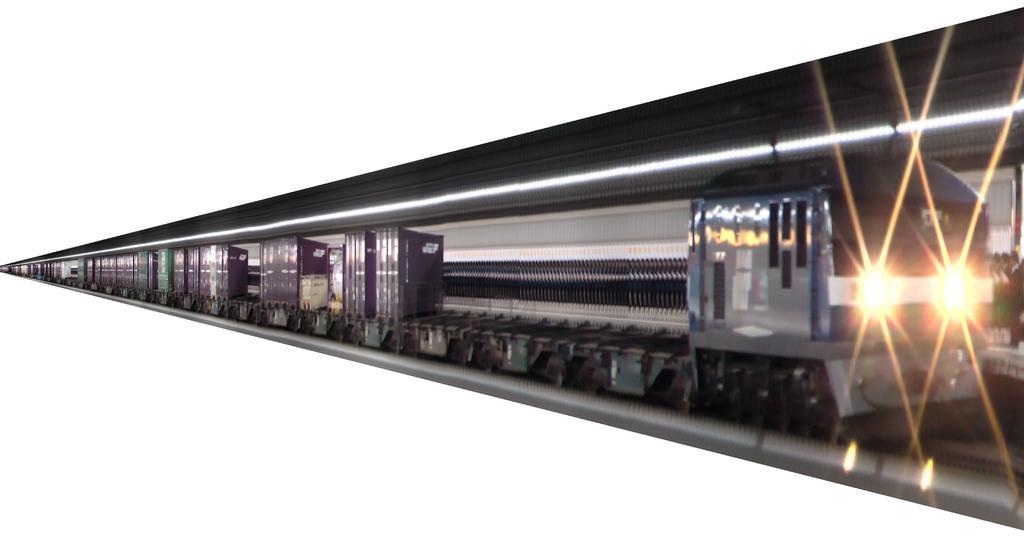Can you describe this image briefly? This is an animated picture. In the center of the image we can see the train. On the right side of the image we can see the roof, lights, railway track and some people are standing on the platform. 